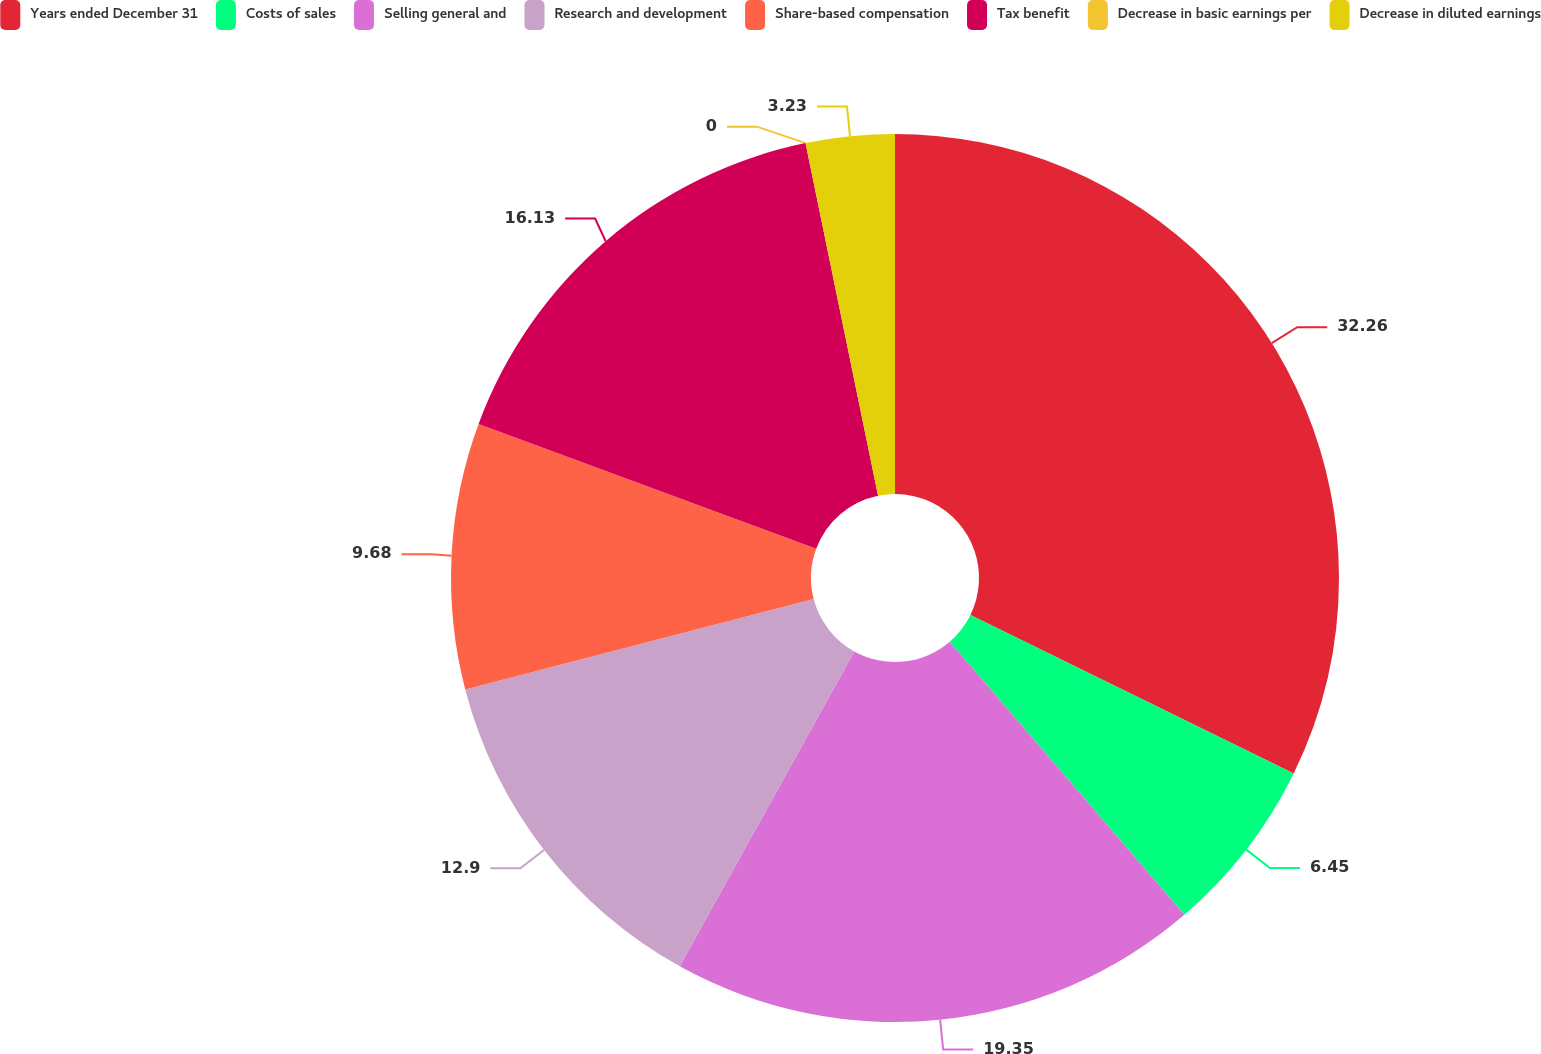Convert chart to OTSL. <chart><loc_0><loc_0><loc_500><loc_500><pie_chart><fcel>Years ended December 31<fcel>Costs of sales<fcel>Selling general and<fcel>Research and development<fcel>Share-based compensation<fcel>Tax benefit<fcel>Decrease in basic earnings per<fcel>Decrease in diluted earnings<nl><fcel>32.25%<fcel>6.45%<fcel>19.35%<fcel>12.9%<fcel>9.68%<fcel>16.13%<fcel>0.0%<fcel>3.23%<nl></chart> 